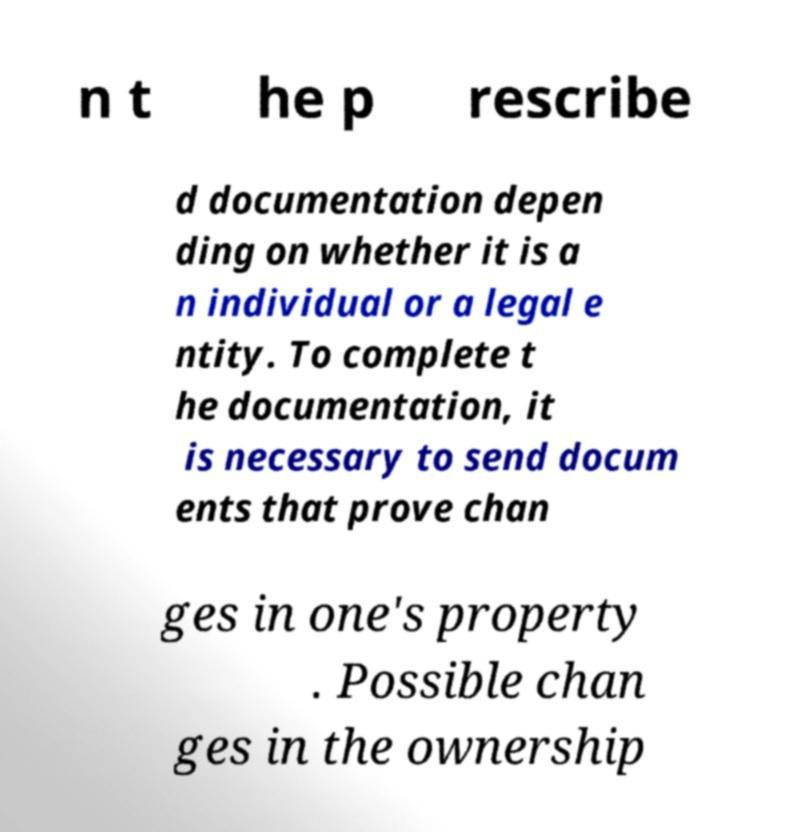Please read and relay the text visible in this image. What does it say? n t he p rescribe d documentation depen ding on whether it is a n individual or a legal e ntity. To complete t he documentation, it is necessary to send docum ents that prove chan ges in one's property . Possible chan ges in the ownership 